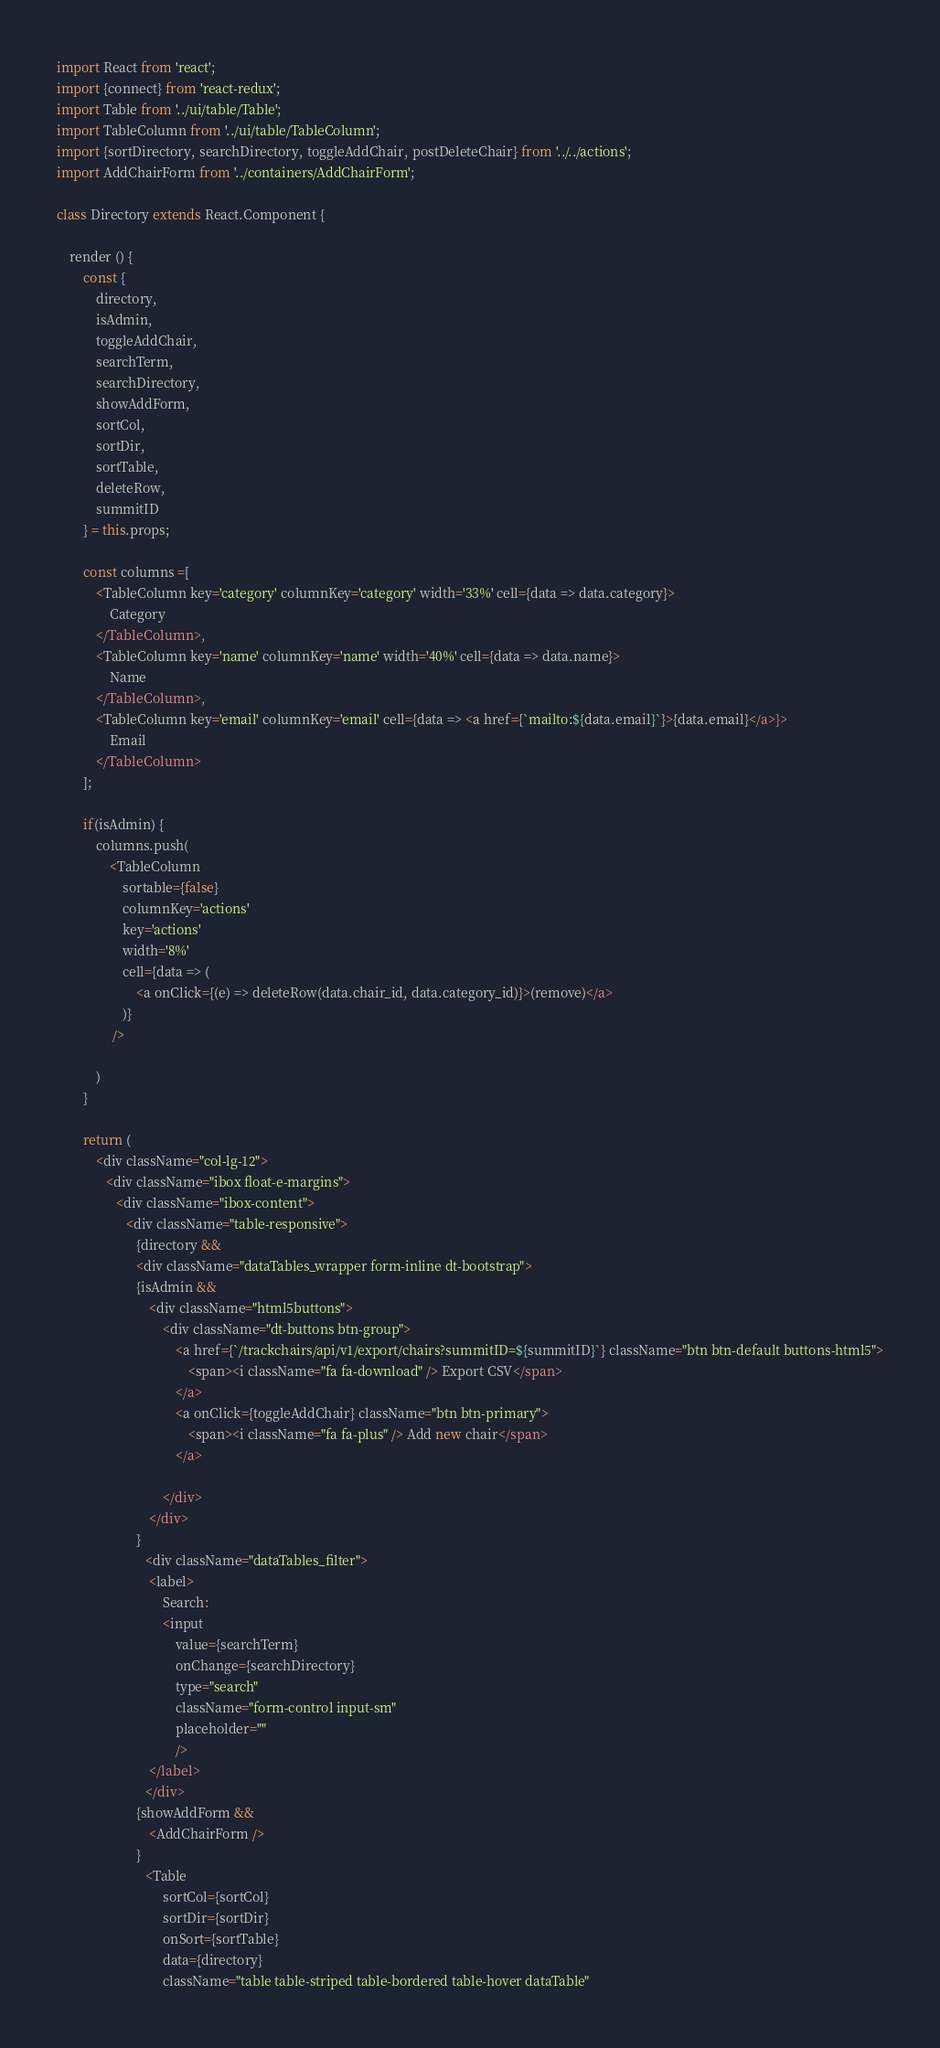<code> <loc_0><loc_0><loc_500><loc_500><_JavaScript_>import React from 'react';
import {connect} from 'react-redux';
import Table from '../ui/table/Table';
import TableColumn from '../ui/table/TableColumn';
import {sortDirectory, searchDirectory, toggleAddChair, postDeleteChair} from '../../actions';
import AddChairForm from '../containers/AddChairForm';

class Directory extends React.Component {

    render () {
    	const {
    		directory, 
    		isAdmin,
    		toggleAddChair, 
    		searchTerm, 
    		searchDirectory, 
    		showAddForm, 
    		sortCol, 
    		sortDir, 
    		sortTable,
    		deleteRow,
			summitID
    	} = this.props;

   		const columns =[
   			<TableColumn key='category' columnKey='category' width='33%' cell={data => data.category}>
   				Category
   			</TableColumn>,
   			<TableColumn key='name' columnKey='name' width='40%' cell={data => data.name}>
   				Name
   			</TableColumn>,
   			<TableColumn key='email' columnKey='email' cell={data => <a href={`mailto:${data.email}`}>{data.email}</a>}>
   				Email
   			</TableColumn>
   		];

   		if(isAdmin) {
   			columns.push(
   				<TableColumn
   					sortable={false}
   					columnKey='actions'
   					key='actions'
   					width='8%'
   					cell={data => (
   						<a onClick={(e) => deleteRow(data.chair_id, data.category_id)}>(remove)</a>
   					)}
   				 />

   			)
   		}

        return (
			<div className="col-lg-12">
			   <div className="ibox float-e-margins">
			      <div className="ibox-content">
			         <div className="table-responsive">
			         	{directory &&
			            <div className="dataTables_wrapper form-inline dt-bootstrap">
			            {isAdmin &&
							<div className="html5buttons">
								<div className="dt-buttons btn-group">
									<a href={`/trackchairs/api/v1/export/chairs?summitID=${summitID}`} className="btn btn-default buttons-html5">
										<span><i className="fa fa-download" /> Export CSV</span>
									</a>
									<a onClick={toggleAddChair} className="btn btn-primary">
										<span><i className="fa fa-plus" /> Add new chair</span>
									</a>

								</div>
							</div>
						}
			               <div className="dataTables_filter">
			               	<label>
			               		Search:
			               		<input
			               			value={searchTerm}
			               			onChange={searchDirectory}
			               			type="search"
			               			className="form-control input-sm"
			               			placeholder=""
			               			/>
			               	</label>
			               </div>
			            {showAddForm &&
			            	<AddChairForm />
			            }
			               <Table
			               		sortCol={sortCol}
			               		sortDir={sortDir}
			               		onSort={sortTable}
			               		data={directory}
			               		className="table table-striped table-bordered table-hover dataTable"</code> 